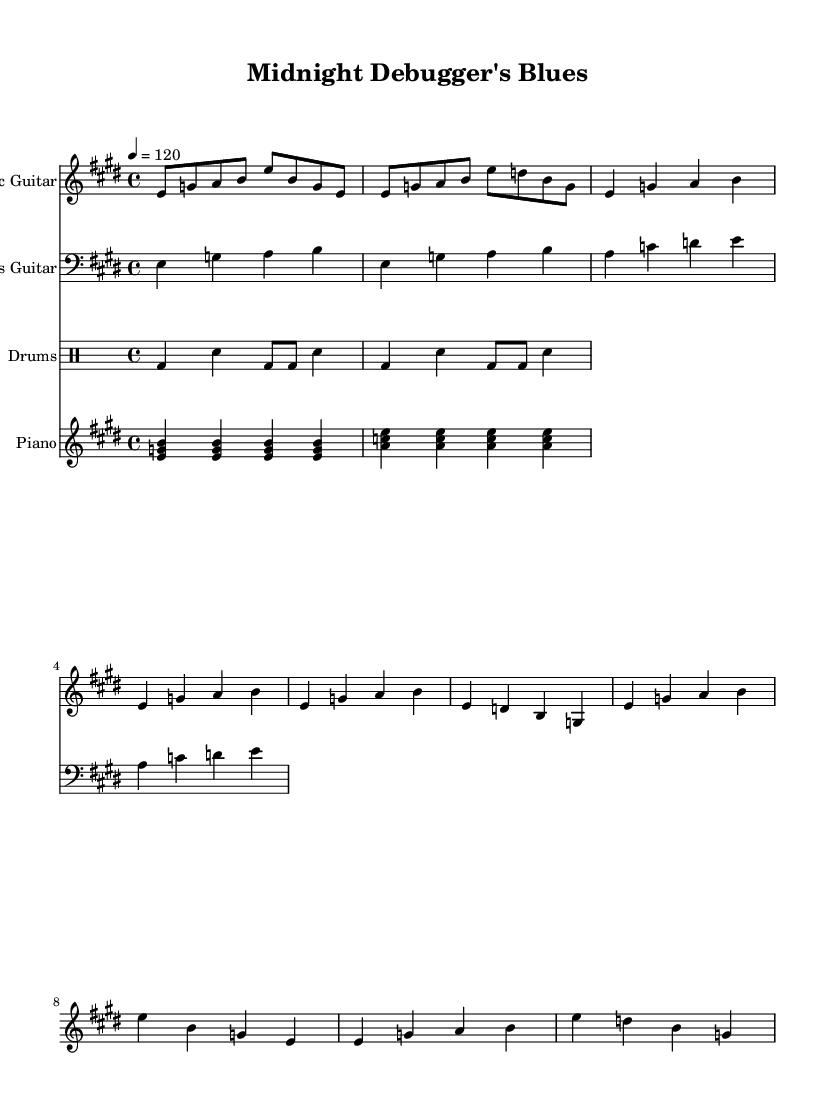what is the key signature of this music? The key signature is E major, which has four sharps (F#, C#, G#, D#). This is visible at the beginning of the sheet music where the key signature is indicated.
Answer: E major what is the time signature of this music? The time signature is 4/4, which is shown at the beginning of the sheet music right after the key signature. This indicates that there are four beats in a measure and the quarter note gets one beat.
Answer: 4/4 what is the tempo of this music? The tempo is marked as 4 = 120, indicating that there are 120 beats per minute. This tempo marking is located beneath the time signature.
Answer: 120 how many measures are in the verse section of the music? The verse section consists of four measures. This can be determined by counting the number of measure bars present in the verse part of the music notation.
Answer: 4 which instrument plays the walking bass line? The bass guitar plays the walking bass line. This is indicated by the staff and clef notation, where the bass guitar part is written in the bass clef.
Answer: Bass guitar which two instruments are marked to play chord comping? The piano plays chord comping along with the electric guitar. This is evident from the separate staves labeled for each instrument, as well as the chords indicated in the piano's section.
Answer: Piano, Electric Guitar describe the drumming pattern used in this music. The drumming pattern is a standard blues shuffle pattern. This can be deduced from the drumming notation shown for the drum part, which typically consists of a bass drum and snare in a shuffle rhythm.
Answer: Blues shuffle 